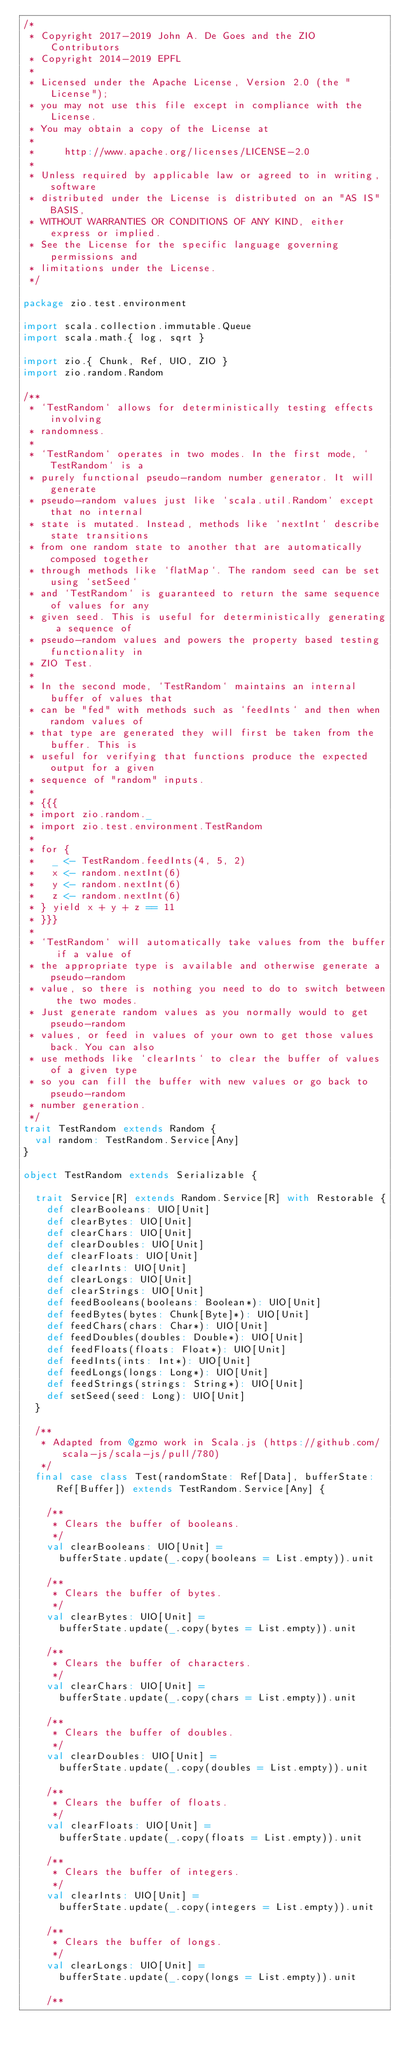Convert code to text. <code><loc_0><loc_0><loc_500><loc_500><_Scala_>/*
 * Copyright 2017-2019 John A. De Goes and the ZIO Contributors
 * Copyright 2014-2019 EPFL
 *
 * Licensed under the Apache License, Version 2.0 (the "License");
 * you may not use this file except in compliance with the License.
 * You may obtain a copy of the License at
 *
 *     http://www.apache.org/licenses/LICENSE-2.0
 *
 * Unless required by applicable law or agreed to in writing, software
 * distributed under the License is distributed on an "AS IS" BASIS,
 * WITHOUT WARRANTIES OR CONDITIONS OF ANY KIND, either express or implied.
 * See the License for the specific language governing permissions and
 * limitations under the License.
 */

package zio.test.environment

import scala.collection.immutable.Queue
import scala.math.{ log, sqrt }

import zio.{ Chunk, Ref, UIO, ZIO }
import zio.random.Random

/**
 * `TestRandom` allows for deterministically testing effects involving
 * randomness.
 *
 * `TestRandom` operates in two modes. In the first mode, `TestRandom` is a
 * purely functional pseudo-random number generator. It will generate
 * pseudo-random values just like `scala.util.Random` except that no internal
 * state is mutated. Instead, methods like `nextInt` describe state transitions
 * from one random state to another that are automatically composed together
 * through methods like `flatMap`. The random seed can be set using `setSeed`
 * and `TestRandom` is guaranteed to return the same sequence of values for any
 * given seed. This is useful for deterministically generating a sequence of
 * pseudo-random values and powers the property based testing functionality in
 * ZIO Test.
 *
 * In the second mode, `TestRandom` maintains an internal buffer of values that
 * can be "fed" with methods such as `feedInts` and then when random values of
 * that type are generated they will first be taken from the buffer. This is
 * useful for verifying that functions produce the expected output for a given
 * sequence of "random" inputs.
 *
 * {{{
 * import zio.random._
 * import zio.test.environment.TestRandom
 *
 * for {
 *   _ <- TestRandom.feedInts(4, 5, 2)
 *   x <- random.nextInt(6)
 *   y <- random.nextInt(6)
 *   z <- random.nextInt(6)
 * } yield x + y + z == 11
 * }}}
 *
 * `TestRandom` will automatically take values from the buffer if a value of
 * the appropriate type is available and otherwise generate a pseudo-random
 * value, so there is nothing you need to do to switch between the two modes.
 * Just generate random values as you normally would to get pseudo-random
 * values, or feed in values of your own to get those values back. You can also
 * use methods like `clearInts` to clear the buffer of values of a given type
 * so you can fill the buffer with new values or go back to pseudo-random
 * number generation.
 */
trait TestRandom extends Random {
  val random: TestRandom.Service[Any]
}

object TestRandom extends Serializable {

  trait Service[R] extends Random.Service[R] with Restorable {
    def clearBooleans: UIO[Unit]
    def clearBytes: UIO[Unit]
    def clearChars: UIO[Unit]
    def clearDoubles: UIO[Unit]
    def clearFloats: UIO[Unit]
    def clearInts: UIO[Unit]
    def clearLongs: UIO[Unit]
    def clearStrings: UIO[Unit]
    def feedBooleans(booleans: Boolean*): UIO[Unit]
    def feedBytes(bytes: Chunk[Byte]*): UIO[Unit]
    def feedChars(chars: Char*): UIO[Unit]
    def feedDoubles(doubles: Double*): UIO[Unit]
    def feedFloats(floats: Float*): UIO[Unit]
    def feedInts(ints: Int*): UIO[Unit]
    def feedLongs(longs: Long*): UIO[Unit]
    def feedStrings(strings: String*): UIO[Unit]
    def setSeed(seed: Long): UIO[Unit]
  }

  /**
   * Adapted from @gzmo work in Scala.js (https://github.com/scala-js/scala-js/pull/780)
   */
  final case class Test(randomState: Ref[Data], bufferState: Ref[Buffer]) extends TestRandom.Service[Any] {

    /**
     * Clears the buffer of booleans.
     */
    val clearBooleans: UIO[Unit] =
      bufferState.update(_.copy(booleans = List.empty)).unit

    /**
     * Clears the buffer of bytes.
     */
    val clearBytes: UIO[Unit] =
      bufferState.update(_.copy(bytes = List.empty)).unit

    /**
     * Clears the buffer of characters.
     */
    val clearChars: UIO[Unit] =
      bufferState.update(_.copy(chars = List.empty)).unit

    /**
     * Clears the buffer of doubles.
     */
    val clearDoubles: UIO[Unit] =
      bufferState.update(_.copy(doubles = List.empty)).unit

    /**
     * Clears the buffer of floats.
     */
    val clearFloats: UIO[Unit] =
      bufferState.update(_.copy(floats = List.empty)).unit

    /**
     * Clears the buffer of integers.
     */
    val clearInts: UIO[Unit] =
      bufferState.update(_.copy(integers = List.empty)).unit

    /**
     * Clears the buffer of longs.
     */
    val clearLongs: UIO[Unit] =
      bufferState.update(_.copy(longs = List.empty)).unit

    /**</code> 